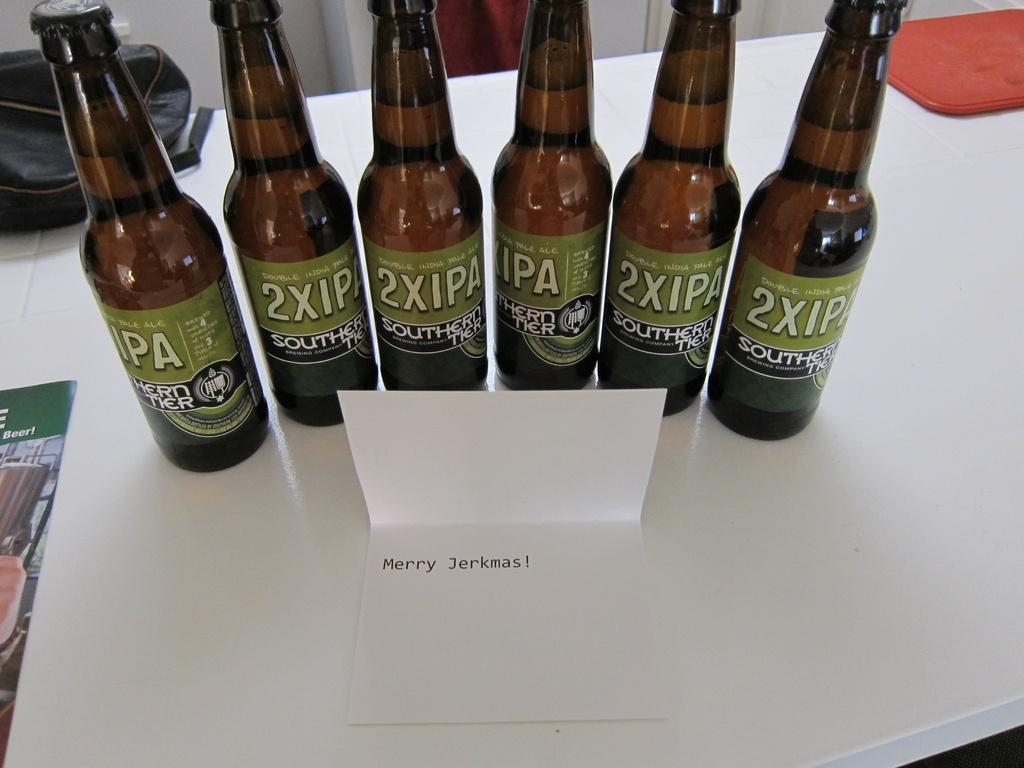<image>
Create a compact narrative representing the image presented. several bottles of 2XIPA sit on display in a row on a table 